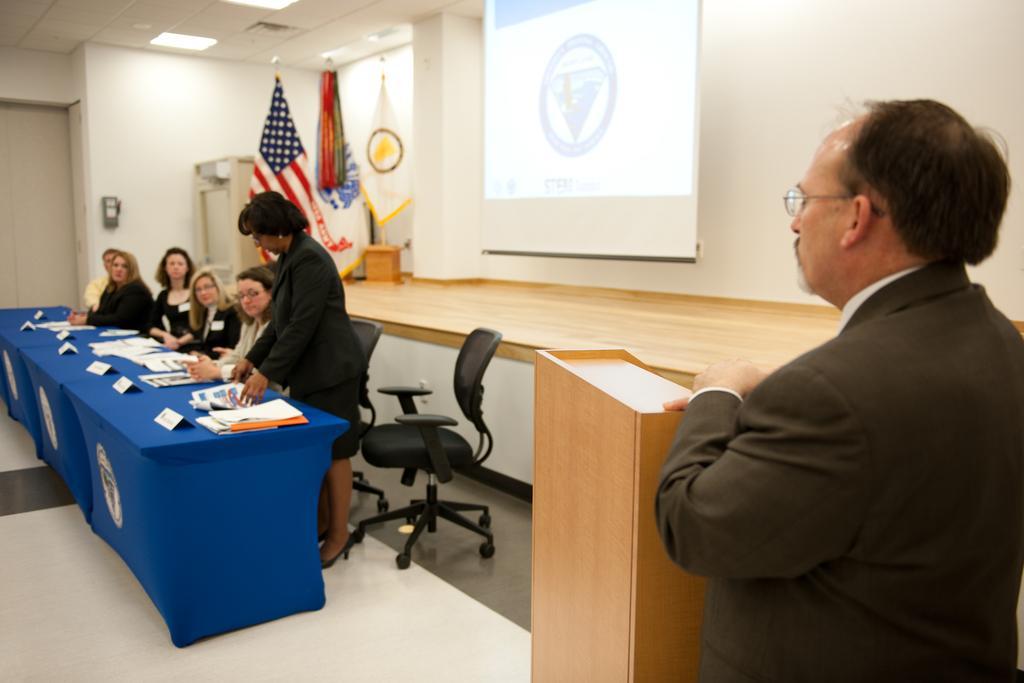Could you give a brief overview of what you see in this image? As we can see in the image there are few women sitting on chairs. In the front there is a table and the man who is standing on the right side is wearing spectacles and there is a screen, flag and white color wall. 